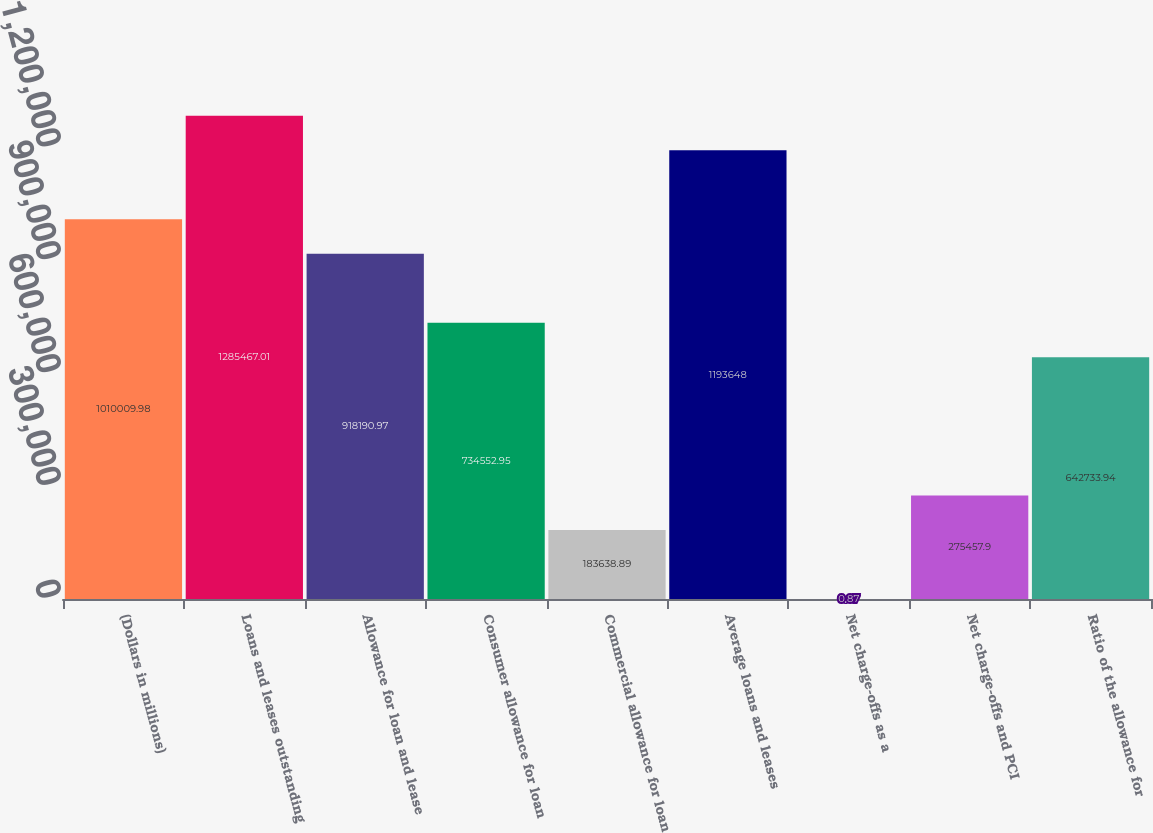Convert chart. <chart><loc_0><loc_0><loc_500><loc_500><bar_chart><fcel>(Dollars in millions)<fcel>Loans and leases outstanding<fcel>Allowance for loan and lease<fcel>Consumer allowance for loan<fcel>Commercial allowance for loan<fcel>Average loans and leases<fcel>Net charge-offs as a<fcel>Net charge-offs and PCI<fcel>Ratio of the allowance for<nl><fcel>1.01001e+06<fcel>1.28547e+06<fcel>918191<fcel>734553<fcel>183639<fcel>1.19365e+06<fcel>0.87<fcel>275458<fcel>642734<nl></chart> 